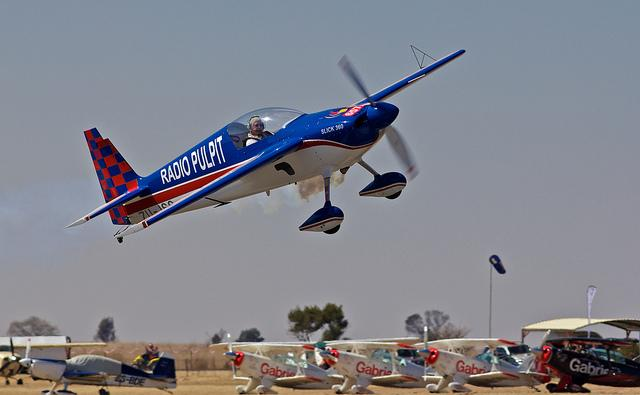What is the man doing in the front of the blue plane? flying 